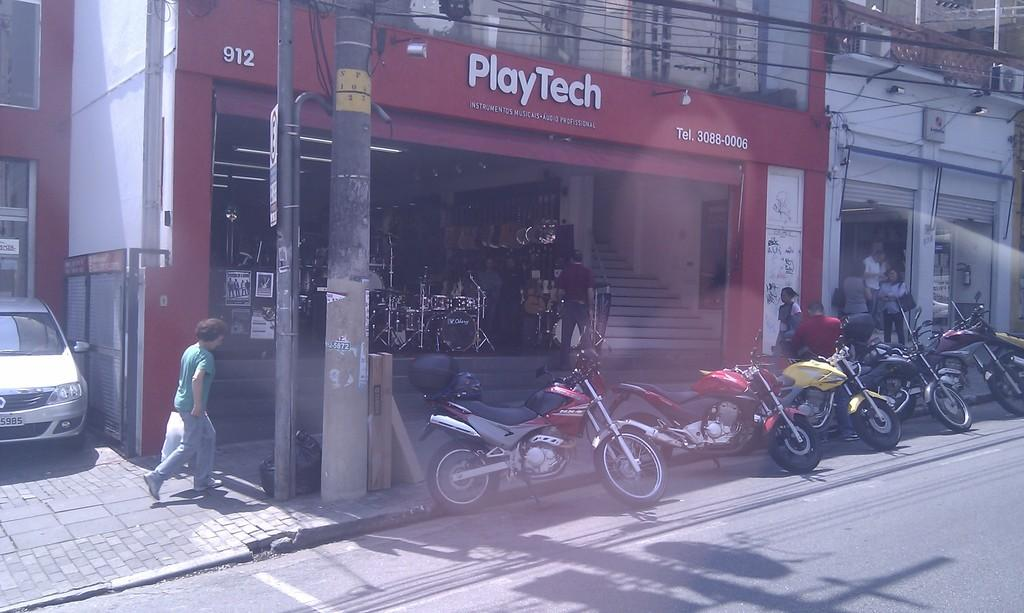What type of structures can be seen in the image? There are buildings in the image. What else can be seen in the image besides buildings? There are poles, wires, bikes, people, a car, and a store visible in the image. Where are the bikes placed in the image? The bikes are placed on the road in the image. What is located on the left side of the image? There is a car on the left side of the image. What type of establishment can be seen in the image? There is a store visible in the image. What type of train can be seen passing through the store in the image? There is no train present in the image; it only features buildings, poles, wires, bikes, people, a car, and a store. Who is the manager of the store in the image? The image does not provide information about the store's management, so it cannot be determined from the image. 